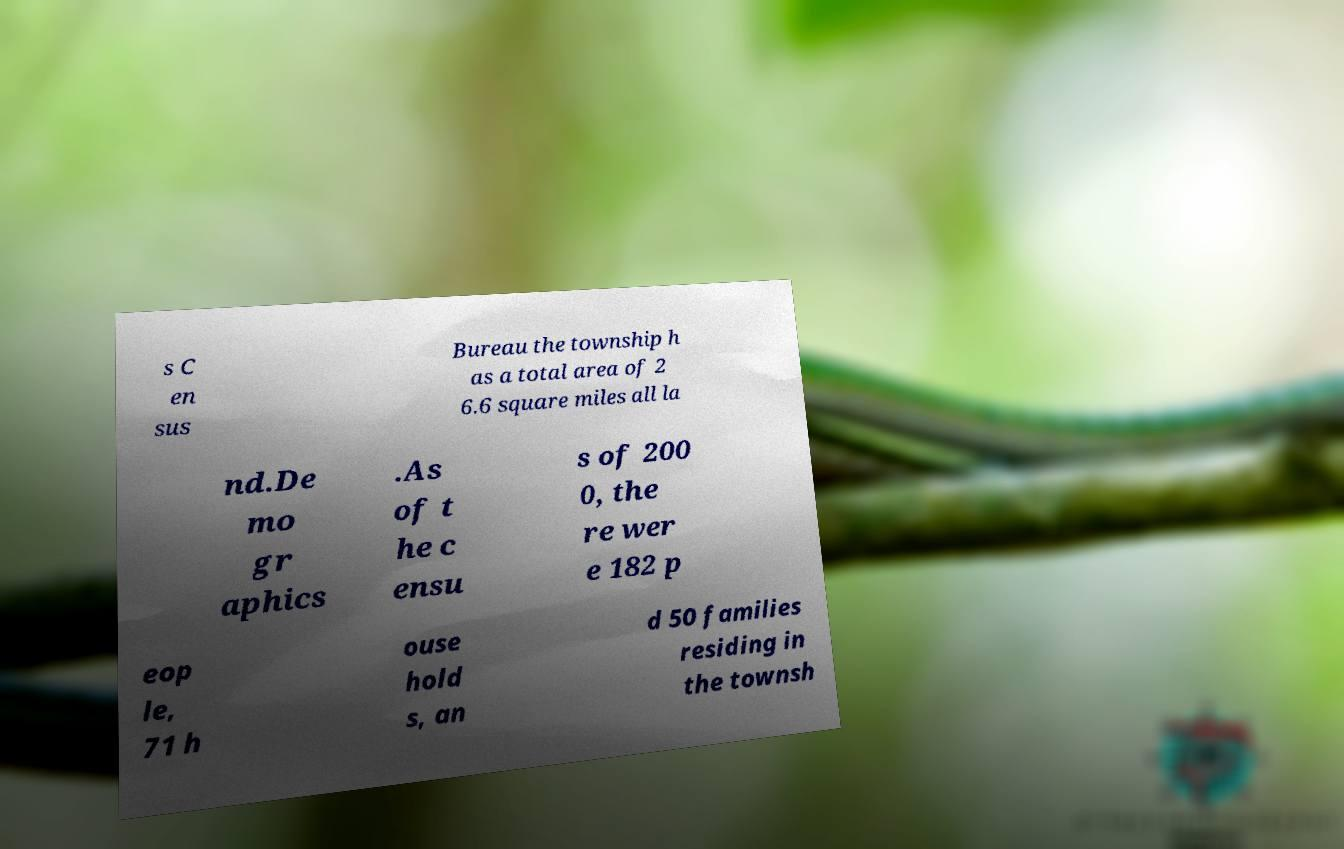I need the written content from this picture converted into text. Can you do that? s C en sus Bureau the township h as a total area of 2 6.6 square miles all la nd.De mo gr aphics .As of t he c ensu s of 200 0, the re wer e 182 p eop le, 71 h ouse hold s, an d 50 families residing in the townsh 